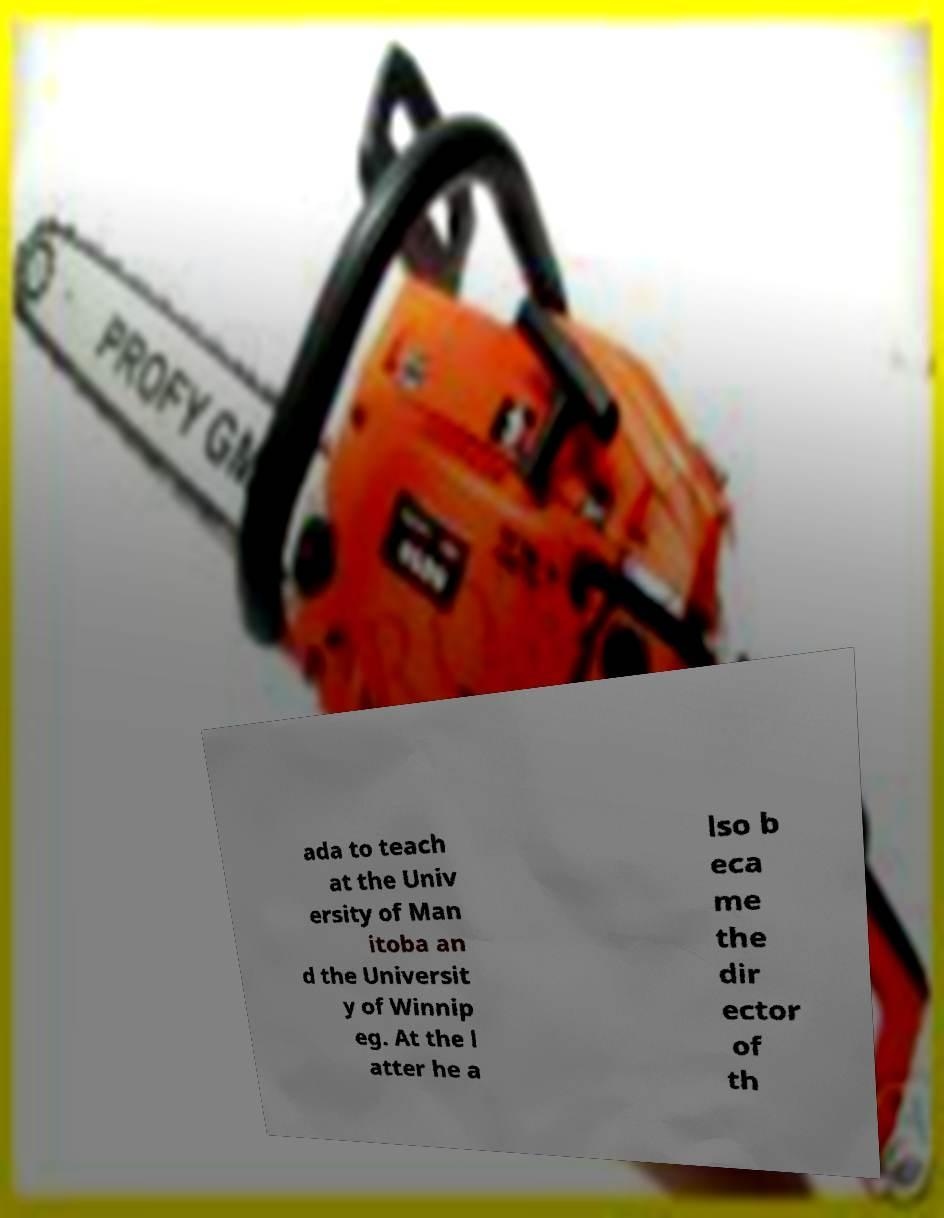I need the written content from this picture converted into text. Can you do that? ada to teach at the Univ ersity of Man itoba an d the Universit y of Winnip eg. At the l atter he a lso b eca me the dir ector of th 